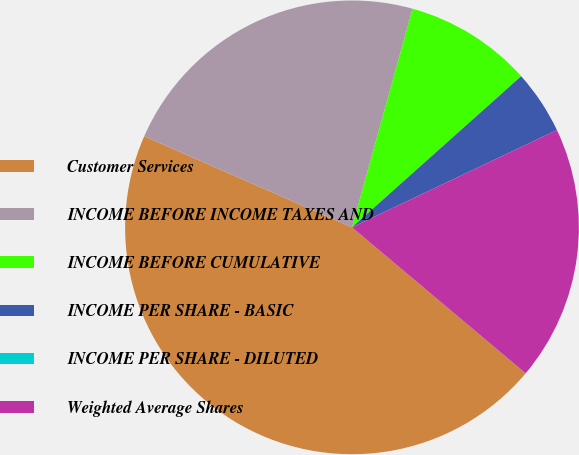Convert chart. <chart><loc_0><loc_0><loc_500><loc_500><pie_chart><fcel>Customer Services<fcel>INCOME BEFORE INCOME TAXES AND<fcel>INCOME BEFORE CUMULATIVE<fcel>INCOME PER SHARE - BASIC<fcel>INCOME PER SHARE - DILUTED<fcel>Weighted Average Shares<nl><fcel>45.45%<fcel>22.73%<fcel>9.09%<fcel>4.55%<fcel>0.0%<fcel>18.18%<nl></chart> 